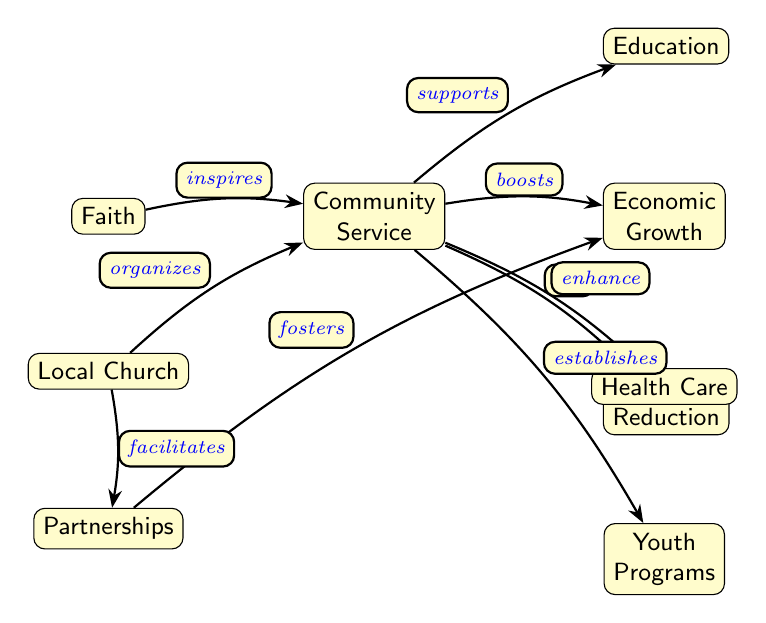What is the topmost node in the diagram? The diagram prominently displays "Faith" as its topmost node.
Answer: Faith How many nodes are shown in the diagram? By counting all distinct entities in the diagram, we find there are eight nodes represented.
Answer: 8 What relationship does the "Local Church" have with "Community Service"? The "Local Church" organizes the "Community Service," indicating a foundational role in this relationship.
Answer: organizes Which node is associated with the concept of "Poverty Reduction"? The "Community Service" node directly aids in the "Poverty Reduction" process, showcasing its crucial supportive role.
Answer: Community Service What do "Partnerships" foster in this diagram? The node "Partnerships" fosters "Economic Growth," indicating an important connection between community collaborations and local economic development.
Answer: Economic Growth Which service enhances "Health Care"? The "Community Service" in the diagram is responsible for enhancing "Health Care," demonstrating its positive impact on health provisions.
Answer: Community Service How is "Education" supported according to the diagram? In the diagram, "Community Service" is shown to support "Education," reflecting the community's commitment to educational improvement.
Answer: supports Describe the connection between "Faith" and "Community Service." The "Faith" node inspires "Community Service," highlighting the motivational role that faith plays in community initiatives.
Answer: inspires What is the direct effect of "Community Service" on "Economic Growth"? The "Community Service" node boosts "Economic Growth," showcasing a direct impact on local economic conditions.
Answer: boosts Which program is established from "Community Service"? "Youth Programs" are established as a result of "Community Service," underlining the community's investment in the youth.
Answer: Youth Programs 